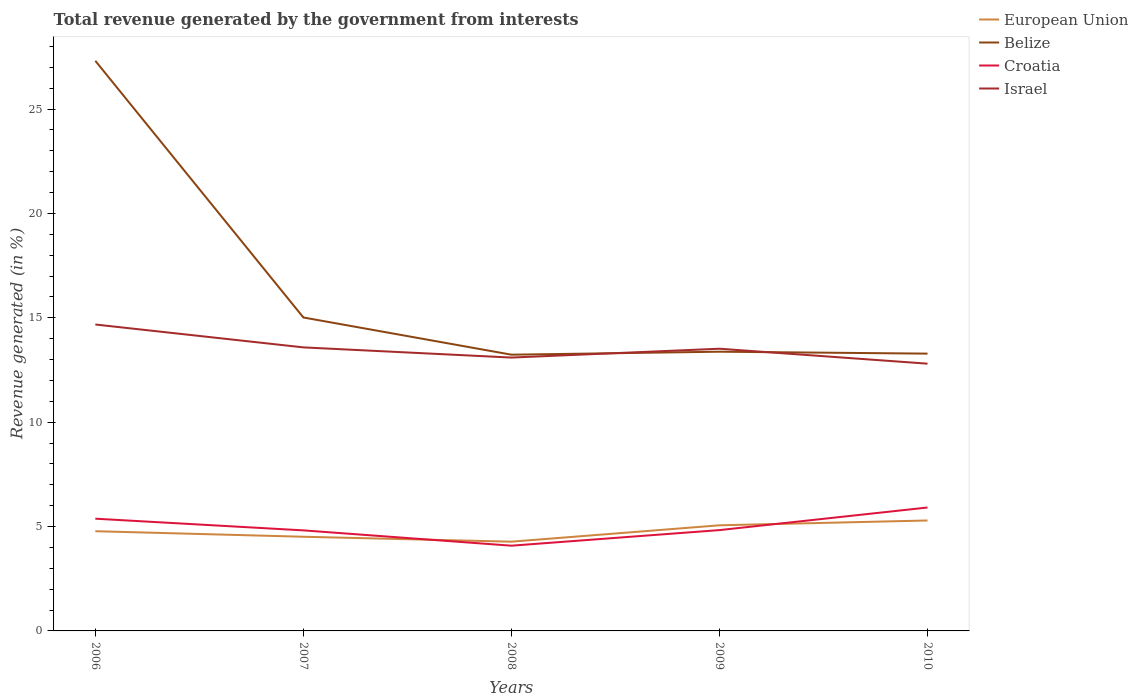How many different coloured lines are there?
Make the answer very short. 4. Across all years, what is the maximum total revenue generated in Belize?
Give a very brief answer. 13.23. In which year was the total revenue generated in European Union maximum?
Your answer should be compact. 2008. What is the total total revenue generated in European Union in the graph?
Your answer should be compact. 0.24. What is the difference between the highest and the second highest total revenue generated in European Union?
Your answer should be compact. 1.02. How many years are there in the graph?
Give a very brief answer. 5. Are the values on the major ticks of Y-axis written in scientific E-notation?
Provide a succinct answer. No. Does the graph contain grids?
Offer a very short reply. No. How are the legend labels stacked?
Offer a very short reply. Vertical. What is the title of the graph?
Give a very brief answer. Total revenue generated by the government from interests. Does "American Samoa" appear as one of the legend labels in the graph?
Provide a short and direct response. No. What is the label or title of the X-axis?
Give a very brief answer. Years. What is the label or title of the Y-axis?
Offer a terse response. Revenue generated (in %). What is the Revenue generated (in %) in European Union in 2006?
Provide a short and direct response. 4.78. What is the Revenue generated (in %) in Belize in 2006?
Provide a short and direct response. 27.31. What is the Revenue generated (in %) in Croatia in 2006?
Give a very brief answer. 5.38. What is the Revenue generated (in %) of Israel in 2006?
Offer a terse response. 14.68. What is the Revenue generated (in %) of European Union in 2007?
Provide a succinct answer. 4.51. What is the Revenue generated (in %) of Belize in 2007?
Ensure brevity in your answer.  15.01. What is the Revenue generated (in %) of Croatia in 2007?
Give a very brief answer. 4.82. What is the Revenue generated (in %) of Israel in 2007?
Keep it short and to the point. 13.58. What is the Revenue generated (in %) of European Union in 2008?
Your answer should be compact. 4.28. What is the Revenue generated (in %) in Belize in 2008?
Provide a succinct answer. 13.23. What is the Revenue generated (in %) of Croatia in 2008?
Provide a succinct answer. 4.08. What is the Revenue generated (in %) in Israel in 2008?
Make the answer very short. 13.09. What is the Revenue generated (in %) in European Union in 2009?
Give a very brief answer. 5.06. What is the Revenue generated (in %) of Belize in 2009?
Offer a very short reply. 13.37. What is the Revenue generated (in %) of Croatia in 2009?
Make the answer very short. 4.83. What is the Revenue generated (in %) of Israel in 2009?
Provide a short and direct response. 13.52. What is the Revenue generated (in %) in European Union in 2010?
Your response must be concise. 5.29. What is the Revenue generated (in %) of Belize in 2010?
Your answer should be very brief. 13.28. What is the Revenue generated (in %) in Croatia in 2010?
Provide a succinct answer. 5.91. What is the Revenue generated (in %) in Israel in 2010?
Offer a very short reply. 12.8. Across all years, what is the maximum Revenue generated (in %) of European Union?
Your response must be concise. 5.29. Across all years, what is the maximum Revenue generated (in %) of Belize?
Your answer should be compact. 27.31. Across all years, what is the maximum Revenue generated (in %) of Croatia?
Offer a terse response. 5.91. Across all years, what is the maximum Revenue generated (in %) in Israel?
Ensure brevity in your answer.  14.68. Across all years, what is the minimum Revenue generated (in %) in European Union?
Provide a succinct answer. 4.28. Across all years, what is the minimum Revenue generated (in %) of Belize?
Ensure brevity in your answer.  13.23. Across all years, what is the minimum Revenue generated (in %) of Croatia?
Ensure brevity in your answer.  4.08. Across all years, what is the minimum Revenue generated (in %) in Israel?
Give a very brief answer. 12.8. What is the total Revenue generated (in %) of European Union in the graph?
Provide a succinct answer. 23.91. What is the total Revenue generated (in %) of Belize in the graph?
Provide a short and direct response. 82.21. What is the total Revenue generated (in %) of Croatia in the graph?
Your answer should be compact. 25.02. What is the total Revenue generated (in %) of Israel in the graph?
Offer a very short reply. 67.67. What is the difference between the Revenue generated (in %) in European Union in 2006 and that in 2007?
Your answer should be compact. 0.27. What is the difference between the Revenue generated (in %) in Belize in 2006 and that in 2007?
Your response must be concise. 12.29. What is the difference between the Revenue generated (in %) of Croatia in 2006 and that in 2007?
Your response must be concise. 0.56. What is the difference between the Revenue generated (in %) of Israel in 2006 and that in 2007?
Offer a very short reply. 1.1. What is the difference between the Revenue generated (in %) of European Union in 2006 and that in 2008?
Provide a succinct answer. 0.5. What is the difference between the Revenue generated (in %) of Belize in 2006 and that in 2008?
Your answer should be compact. 14.08. What is the difference between the Revenue generated (in %) in Croatia in 2006 and that in 2008?
Your answer should be compact. 1.29. What is the difference between the Revenue generated (in %) of Israel in 2006 and that in 2008?
Keep it short and to the point. 1.58. What is the difference between the Revenue generated (in %) in European Union in 2006 and that in 2009?
Make the answer very short. -0.28. What is the difference between the Revenue generated (in %) of Belize in 2006 and that in 2009?
Your answer should be very brief. 13.93. What is the difference between the Revenue generated (in %) of Croatia in 2006 and that in 2009?
Your answer should be very brief. 0.55. What is the difference between the Revenue generated (in %) of Israel in 2006 and that in 2009?
Offer a very short reply. 1.16. What is the difference between the Revenue generated (in %) in European Union in 2006 and that in 2010?
Ensure brevity in your answer.  -0.51. What is the difference between the Revenue generated (in %) of Belize in 2006 and that in 2010?
Give a very brief answer. 14.03. What is the difference between the Revenue generated (in %) of Croatia in 2006 and that in 2010?
Provide a succinct answer. -0.54. What is the difference between the Revenue generated (in %) in Israel in 2006 and that in 2010?
Keep it short and to the point. 1.88. What is the difference between the Revenue generated (in %) in European Union in 2007 and that in 2008?
Your answer should be compact. 0.24. What is the difference between the Revenue generated (in %) of Belize in 2007 and that in 2008?
Provide a short and direct response. 1.78. What is the difference between the Revenue generated (in %) in Croatia in 2007 and that in 2008?
Offer a terse response. 0.73. What is the difference between the Revenue generated (in %) of Israel in 2007 and that in 2008?
Offer a terse response. 0.49. What is the difference between the Revenue generated (in %) of European Union in 2007 and that in 2009?
Provide a succinct answer. -0.55. What is the difference between the Revenue generated (in %) of Belize in 2007 and that in 2009?
Keep it short and to the point. 1.64. What is the difference between the Revenue generated (in %) in Croatia in 2007 and that in 2009?
Offer a terse response. -0.01. What is the difference between the Revenue generated (in %) in Israel in 2007 and that in 2009?
Provide a short and direct response. 0.06. What is the difference between the Revenue generated (in %) in European Union in 2007 and that in 2010?
Make the answer very short. -0.78. What is the difference between the Revenue generated (in %) in Belize in 2007 and that in 2010?
Give a very brief answer. 1.73. What is the difference between the Revenue generated (in %) in Croatia in 2007 and that in 2010?
Your response must be concise. -1.1. What is the difference between the Revenue generated (in %) in Israel in 2007 and that in 2010?
Provide a short and direct response. 0.78. What is the difference between the Revenue generated (in %) in European Union in 2008 and that in 2009?
Offer a very short reply. -0.78. What is the difference between the Revenue generated (in %) in Belize in 2008 and that in 2009?
Ensure brevity in your answer.  -0.14. What is the difference between the Revenue generated (in %) of Croatia in 2008 and that in 2009?
Ensure brevity in your answer.  -0.75. What is the difference between the Revenue generated (in %) of Israel in 2008 and that in 2009?
Your answer should be compact. -0.42. What is the difference between the Revenue generated (in %) of European Union in 2008 and that in 2010?
Make the answer very short. -1.01. What is the difference between the Revenue generated (in %) of Belize in 2008 and that in 2010?
Offer a terse response. -0.05. What is the difference between the Revenue generated (in %) of Croatia in 2008 and that in 2010?
Offer a very short reply. -1.83. What is the difference between the Revenue generated (in %) of Israel in 2008 and that in 2010?
Your answer should be very brief. 0.29. What is the difference between the Revenue generated (in %) in European Union in 2009 and that in 2010?
Your answer should be compact. -0.23. What is the difference between the Revenue generated (in %) in Belize in 2009 and that in 2010?
Provide a succinct answer. 0.09. What is the difference between the Revenue generated (in %) of Croatia in 2009 and that in 2010?
Give a very brief answer. -1.08. What is the difference between the Revenue generated (in %) of Israel in 2009 and that in 2010?
Offer a very short reply. 0.72. What is the difference between the Revenue generated (in %) in European Union in 2006 and the Revenue generated (in %) in Belize in 2007?
Your answer should be very brief. -10.24. What is the difference between the Revenue generated (in %) in European Union in 2006 and the Revenue generated (in %) in Croatia in 2007?
Offer a terse response. -0.04. What is the difference between the Revenue generated (in %) of European Union in 2006 and the Revenue generated (in %) of Israel in 2007?
Give a very brief answer. -8.81. What is the difference between the Revenue generated (in %) of Belize in 2006 and the Revenue generated (in %) of Croatia in 2007?
Offer a terse response. 22.49. What is the difference between the Revenue generated (in %) in Belize in 2006 and the Revenue generated (in %) in Israel in 2007?
Your answer should be very brief. 13.73. What is the difference between the Revenue generated (in %) in Croatia in 2006 and the Revenue generated (in %) in Israel in 2007?
Provide a short and direct response. -8.21. What is the difference between the Revenue generated (in %) in European Union in 2006 and the Revenue generated (in %) in Belize in 2008?
Your answer should be very brief. -8.46. What is the difference between the Revenue generated (in %) of European Union in 2006 and the Revenue generated (in %) of Croatia in 2008?
Your answer should be compact. 0.69. What is the difference between the Revenue generated (in %) in European Union in 2006 and the Revenue generated (in %) in Israel in 2008?
Provide a succinct answer. -8.32. What is the difference between the Revenue generated (in %) in Belize in 2006 and the Revenue generated (in %) in Croatia in 2008?
Give a very brief answer. 23.23. What is the difference between the Revenue generated (in %) in Belize in 2006 and the Revenue generated (in %) in Israel in 2008?
Make the answer very short. 14.21. What is the difference between the Revenue generated (in %) of Croatia in 2006 and the Revenue generated (in %) of Israel in 2008?
Provide a succinct answer. -7.72. What is the difference between the Revenue generated (in %) of European Union in 2006 and the Revenue generated (in %) of Belize in 2009?
Your response must be concise. -8.6. What is the difference between the Revenue generated (in %) in European Union in 2006 and the Revenue generated (in %) in Croatia in 2009?
Give a very brief answer. -0.05. What is the difference between the Revenue generated (in %) in European Union in 2006 and the Revenue generated (in %) in Israel in 2009?
Your answer should be compact. -8.74. What is the difference between the Revenue generated (in %) of Belize in 2006 and the Revenue generated (in %) of Croatia in 2009?
Ensure brevity in your answer.  22.48. What is the difference between the Revenue generated (in %) of Belize in 2006 and the Revenue generated (in %) of Israel in 2009?
Offer a terse response. 13.79. What is the difference between the Revenue generated (in %) of Croatia in 2006 and the Revenue generated (in %) of Israel in 2009?
Offer a very short reply. -8.14. What is the difference between the Revenue generated (in %) in European Union in 2006 and the Revenue generated (in %) in Belize in 2010?
Give a very brief answer. -8.51. What is the difference between the Revenue generated (in %) in European Union in 2006 and the Revenue generated (in %) in Croatia in 2010?
Provide a succinct answer. -1.14. What is the difference between the Revenue generated (in %) of European Union in 2006 and the Revenue generated (in %) of Israel in 2010?
Provide a succinct answer. -8.03. What is the difference between the Revenue generated (in %) in Belize in 2006 and the Revenue generated (in %) in Croatia in 2010?
Give a very brief answer. 21.4. What is the difference between the Revenue generated (in %) in Belize in 2006 and the Revenue generated (in %) in Israel in 2010?
Give a very brief answer. 14.51. What is the difference between the Revenue generated (in %) in Croatia in 2006 and the Revenue generated (in %) in Israel in 2010?
Give a very brief answer. -7.43. What is the difference between the Revenue generated (in %) of European Union in 2007 and the Revenue generated (in %) of Belize in 2008?
Your response must be concise. -8.72. What is the difference between the Revenue generated (in %) of European Union in 2007 and the Revenue generated (in %) of Croatia in 2008?
Your answer should be very brief. 0.43. What is the difference between the Revenue generated (in %) of European Union in 2007 and the Revenue generated (in %) of Israel in 2008?
Your answer should be compact. -8.58. What is the difference between the Revenue generated (in %) in Belize in 2007 and the Revenue generated (in %) in Croatia in 2008?
Provide a succinct answer. 10.93. What is the difference between the Revenue generated (in %) of Belize in 2007 and the Revenue generated (in %) of Israel in 2008?
Give a very brief answer. 1.92. What is the difference between the Revenue generated (in %) of Croatia in 2007 and the Revenue generated (in %) of Israel in 2008?
Keep it short and to the point. -8.28. What is the difference between the Revenue generated (in %) in European Union in 2007 and the Revenue generated (in %) in Belize in 2009?
Provide a short and direct response. -8.86. What is the difference between the Revenue generated (in %) of European Union in 2007 and the Revenue generated (in %) of Croatia in 2009?
Give a very brief answer. -0.32. What is the difference between the Revenue generated (in %) of European Union in 2007 and the Revenue generated (in %) of Israel in 2009?
Provide a short and direct response. -9.01. What is the difference between the Revenue generated (in %) of Belize in 2007 and the Revenue generated (in %) of Croatia in 2009?
Offer a very short reply. 10.18. What is the difference between the Revenue generated (in %) of Belize in 2007 and the Revenue generated (in %) of Israel in 2009?
Make the answer very short. 1.5. What is the difference between the Revenue generated (in %) in Croatia in 2007 and the Revenue generated (in %) in Israel in 2009?
Your response must be concise. -8.7. What is the difference between the Revenue generated (in %) in European Union in 2007 and the Revenue generated (in %) in Belize in 2010?
Your response must be concise. -8.77. What is the difference between the Revenue generated (in %) of European Union in 2007 and the Revenue generated (in %) of Croatia in 2010?
Your answer should be compact. -1.4. What is the difference between the Revenue generated (in %) of European Union in 2007 and the Revenue generated (in %) of Israel in 2010?
Offer a very short reply. -8.29. What is the difference between the Revenue generated (in %) of Belize in 2007 and the Revenue generated (in %) of Croatia in 2010?
Ensure brevity in your answer.  9.1. What is the difference between the Revenue generated (in %) of Belize in 2007 and the Revenue generated (in %) of Israel in 2010?
Make the answer very short. 2.21. What is the difference between the Revenue generated (in %) of Croatia in 2007 and the Revenue generated (in %) of Israel in 2010?
Provide a succinct answer. -7.99. What is the difference between the Revenue generated (in %) of European Union in 2008 and the Revenue generated (in %) of Belize in 2009?
Offer a very short reply. -9.1. What is the difference between the Revenue generated (in %) of European Union in 2008 and the Revenue generated (in %) of Croatia in 2009?
Make the answer very short. -0.55. What is the difference between the Revenue generated (in %) in European Union in 2008 and the Revenue generated (in %) in Israel in 2009?
Make the answer very short. -9.24. What is the difference between the Revenue generated (in %) in Belize in 2008 and the Revenue generated (in %) in Croatia in 2009?
Offer a very short reply. 8.4. What is the difference between the Revenue generated (in %) in Belize in 2008 and the Revenue generated (in %) in Israel in 2009?
Provide a succinct answer. -0.29. What is the difference between the Revenue generated (in %) of Croatia in 2008 and the Revenue generated (in %) of Israel in 2009?
Ensure brevity in your answer.  -9.43. What is the difference between the Revenue generated (in %) in European Union in 2008 and the Revenue generated (in %) in Belize in 2010?
Make the answer very short. -9.01. What is the difference between the Revenue generated (in %) in European Union in 2008 and the Revenue generated (in %) in Croatia in 2010?
Offer a very short reply. -1.64. What is the difference between the Revenue generated (in %) in European Union in 2008 and the Revenue generated (in %) in Israel in 2010?
Offer a very short reply. -8.53. What is the difference between the Revenue generated (in %) of Belize in 2008 and the Revenue generated (in %) of Croatia in 2010?
Provide a succinct answer. 7.32. What is the difference between the Revenue generated (in %) in Belize in 2008 and the Revenue generated (in %) in Israel in 2010?
Give a very brief answer. 0.43. What is the difference between the Revenue generated (in %) in Croatia in 2008 and the Revenue generated (in %) in Israel in 2010?
Your response must be concise. -8.72. What is the difference between the Revenue generated (in %) in European Union in 2009 and the Revenue generated (in %) in Belize in 2010?
Provide a short and direct response. -8.22. What is the difference between the Revenue generated (in %) in European Union in 2009 and the Revenue generated (in %) in Croatia in 2010?
Your answer should be compact. -0.85. What is the difference between the Revenue generated (in %) of European Union in 2009 and the Revenue generated (in %) of Israel in 2010?
Make the answer very short. -7.74. What is the difference between the Revenue generated (in %) of Belize in 2009 and the Revenue generated (in %) of Croatia in 2010?
Provide a succinct answer. 7.46. What is the difference between the Revenue generated (in %) of Belize in 2009 and the Revenue generated (in %) of Israel in 2010?
Make the answer very short. 0.57. What is the difference between the Revenue generated (in %) of Croatia in 2009 and the Revenue generated (in %) of Israel in 2010?
Your response must be concise. -7.97. What is the average Revenue generated (in %) of European Union per year?
Make the answer very short. 4.78. What is the average Revenue generated (in %) in Belize per year?
Provide a succinct answer. 16.44. What is the average Revenue generated (in %) in Croatia per year?
Your answer should be very brief. 5. What is the average Revenue generated (in %) of Israel per year?
Keep it short and to the point. 13.53. In the year 2006, what is the difference between the Revenue generated (in %) of European Union and Revenue generated (in %) of Belize?
Provide a succinct answer. -22.53. In the year 2006, what is the difference between the Revenue generated (in %) of European Union and Revenue generated (in %) of Croatia?
Your answer should be very brief. -0.6. In the year 2006, what is the difference between the Revenue generated (in %) in European Union and Revenue generated (in %) in Israel?
Ensure brevity in your answer.  -9.9. In the year 2006, what is the difference between the Revenue generated (in %) in Belize and Revenue generated (in %) in Croatia?
Offer a terse response. 21.93. In the year 2006, what is the difference between the Revenue generated (in %) of Belize and Revenue generated (in %) of Israel?
Give a very brief answer. 12.63. In the year 2006, what is the difference between the Revenue generated (in %) of Croatia and Revenue generated (in %) of Israel?
Offer a terse response. -9.3. In the year 2007, what is the difference between the Revenue generated (in %) in European Union and Revenue generated (in %) in Belize?
Ensure brevity in your answer.  -10.5. In the year 2007, what is the difference between the Revenue generated (in %) in European Union and Revenue generated (in %) in Croatia?
Give a very brief answer. -0.31. In the year 2007, what is the difference between the Revenue generated (in %) in European Union and Revenue generated (in %) in Israel?
Keep it short and to the point. -9.07. In the year 2007, what is the difference between the Revenue generated (in %) in Belize and Revenue generated (in %) in Croatia?
Give a very brief answer. 10.2. In the year 2007, what is the difference between the Revenue generated (in %) in Belize and Revenue generated (in %) in Israel?
Provide a short and direct response. 1.43. In the year 2007, what is the difference between the Revenue generated (in %) in Croatia and Revenue generated (in %) in Israel?
Your response must be concise. -8.77. In the year 2008, what is the difference between the Revenue generated (in %) in European Union and Revenue generated (in %) in Belize?
Offer a very short reply. -8.96. In the year 2008, what is the difference between the Revenue generated (in %) of European Union and Revenue generated (in %) of Croatia?
Your answer should be compact. 0.19. In the year 2008, what is the difference between the Revenue generated (in %) in European Union and Revenue generated (in %) in Israel?
Make the answer very short. -8.82. In the year 2008, what is the difference between the Revenue generated (in %) in Belize and Revenue generated (in %) in Croatia?
Provide a succinct answer. 9.15. In the year 2008, what is the difference between the Revenue generated (in %) of Belize and Revenue generated (in %) of Israel?
Your response must be concise. 0.14. In the year 2008, what is the difference between the Revenue generated (in %) in Croatia and Revenue generated (in %) in Israel?
Offer a very short reply. -9.01. In the year 2009, what is the difference between the Revenue generated (in %) of European Union and Revenue generated (in %) of Belize?
Give a very brief answer. -8.32. In the year 2009, what is the difference between the Revenue generated (in %) of European Union and Revenue generated (in %) of Croatia?
Give a very brief answer. 0.23. In the year 2009, what is the difference between the Revenue generated (in %) in European Union and Revenue generated (in %) in Israel?
Your answer should be very brief. -8.46. In the year 2009, what is the difference between the Revenue generated (in %) of Belize and Revenue generated (in %) of Croatia?
Give a very brief answer. 8.55. In the year 2009, what is the difference between the Revenue generated (in %) of Belize and Revenue generated (in %) of Israel?
Provide a succinct answer. -0.14. In the year 2009, what is the difference between the Revenue generated (in %) of Croatia and Revenue generated (in %) of Israel?
Your answer should be compact. -8.69. In the year 2010, what is the difference between the Revenue generated (in %) of European Union and Revenue generated (in %) of Belize?
Provide a succinct answer. -7.99. In the year 2010, what is the difference between the Revenue generated (in %) of European Union and Revenue generated (in %) of Croatia?
Your answer should be compact. -0.62. In the year 2010, what is the difference between the Revenue generated (in %) of European Union and Revenue generated (in %) of Israel?
Your answer should be compact. -7.51. In the year 2010, what is the difference between the Revenue generated (in %) of Belize and Revenue generated (in %) of Croatia?
Provide a short and direct response. 7.37. In the year 2010, what is the difference between the Revenue generated (in %) of Belize and Revenue generated (in %) of Israel?
Provide a succinct answer. 0.48. In the year 2010, what is the difference between the Revenue generated (in %) of Croatia and Revenue generated (in %) of Israel?
Your answer should be very brief. -6.89. What is the ratio of the Revenue generated (in %) of European Union in 2006 to that in 2007?
Ensure brevity in your answer.  1.06. What is the ratio of the Revenue generated (in %) in Belize in 2006 to that in 2007?
Your response must be concise. 1.82. What is the ratio of the Revenue generated (in %) in Croatia in 2006 to that in 2007?
Make the answer very short. 1.12. What is the ratio of the Revenue generated (in %) in Israel in 2006 to that in 2007?
Offer a very short reply. 1.08. What is the ratio of the Revenue generated (in %) of European Union in 2006 to that in 2008?
Your answer should be compact. 1.12. What is the ratio of the Revenue generated (in %) in Belize in 2006 to that in 2008?
Make the answer very short. 2.06. What is the ratio of the Revenue generated (in %) in Croatia in 2006 to that in 2008?
Offer a very short reply. 1.32. What is the ratio of the Revenue generated (in %) of Israel in 2006 to that in 2008?
Your answer should be very brief. 1.12. What is the ratio of the Revenue generated (in %) of European Union in 2006 to that in 2009?
Ensure brevity in your answer.  0.94. What is the ratio of the Revenue generated (in %) of Belize in 2006 to that in 2009?
Make the answer very short. 2.04. What is the ratio of the Revenue generated (in %) in Croatia in 2006 to that in 2009?
Offer a terse response. 1.11. What is the ratio of the Revenue generated (in %) of Israel in 2006 to that in 2009?
Make the answer very short. 1.09. What is the ratio of the Revenue generated (in %) of European Union in 2006 to that in 2010?
Provide a succinct answer. 0.9. What is the ratio of the Revenue generated (in %) in Belize in 2006 to that in 2010?
Make the answer very short. 2.06. What is the ratio of the Revenue generated (in %) in Croatia in 2006 to that in 2010?
Your response must be concise. 0.91. What is the ratio of the Revenue generated (in %) of Israel in 2006 to that in 2010?
Ensure brevity in your answer.  1.15. What is the ratio of the Revenue generated (in %) in European Union in 2007 to that in 2008?
Your response must be concise. 1.06. What is the ratio of the Revenue generated (in %) of Belize in 2007 to that in 2008?
Offer a very short reply. 1.13. What is the ratio of the Revenue generated (in %) of Croatia in 2007 to that in 2008?
Offer a terse response. 1.18. What is the ratio of the Revenue generated (in %) of Israel in 2007 to that in 2008?
Offer a very short reply. 1.04. What is the ratio of the Revenue generated (in %) in European Union in 2007 to that in 2009?
Your response must be concise. 0.89. What is the ratio of the Revenue generated (in %) of Belize in 2007 to that in 2009?
Offer a terse response. 1.12. What is the ratio of the Revenue generated (in %) in Croatia in 2007 to that in 2009?
Provide a succinct answer. 1. What is the ratio of the Revenue generated (in %) in Israel in 2007 to that in 2009?
Ensure brevity in your answer.  1. What is the ratio of the Revenue generated (in %) in European Union in 2007 to that in 2010?
Your response must be concise. 0.85. What is the ratio of the Revenue generated (in %) in Belize in 2007 to that in 2010?
Your answer should be compact. 1.13. What is the ratio of the Revenue generated (in %) of Croatia in 2007 to that in 2010?
Give a very brief answer. 0.81. What is the ratio of the Revenue generated (in %) in Israel in 2007 to that in 2010?
Keep it short and to the point. 1.06. What is the ratio of the Revenue generated (in %) of European Union in 2008 to that in 2009?
Offer a terse response. 0.84. What is the ratio of the Revenue generated (in %) in Belize in 2008 to that in 2009?
Make the answer very short. 0.99. What is the ratio of the Revenue generated (in %) in Croatia in 2008 to that in 2009?
Make the answer very short. 0.85. What is the ratio of the Revenue generated (in %) in Israel in 2008 to that in 2009?
Give a very brief answer. 0.97. What is the ratio of the Revenue generated (in %) of European Union in 2008 to that in 2010?
Offer a terse response. 0.81. What is the ratio of the Revenue generated (in %) in Croatia in 2008 to that in 2010?
Provide a succinct answer. 0.69. What is the ratio of the Revenue generated (in %) in Israel in 2008 to that in 2010?
Your response must be concise. 1.02. What is the ratio of the Revenue generated (in %) of European Union in 2009 to that in 2010?
Offer a very short reply. 0.96. What is the ratio of the Revenue generated (in %) in Croatia in 2009 to that in 2010?
Your response must be concise. 0.82. What is the ratio of the Revenue generated (in %) in Israel in 2009 to that in 2010?
Keep it short and to the point. 1.06. What is the difference between the highest and the second highest Revenue generated (in %) of European Union?
Provide a short and direct response. 0.23. What is the difference between the highest and the second highest Revenue generated (in %) of Belize?
Your response must be concise. 12.29. What is the difference between the highest and the second highest Revenue generated (in %) of Croatia?
Ensure brevity in your answer.  0.54. What is the difference between the highest and the second highest Revenue generated (in %) of Israel?
Give a very brief answer. 1.1. What is the difference between the highest and the lowest Revenue generated (in %) of European Union?
Make the answer very short. 1.01. What is the difference between the highest and the lowest Revenue generated (in %) of Belize?
Offer a very short reply. 14.08. What is the difference between the highest and the lowest Revenue generated (in %) in Croatia?
Offer a very short reply. 1.83. What is the difference between the highest and the lowest Revenue generated (in %) in Israel?
Your response must be concise. 1.88. 